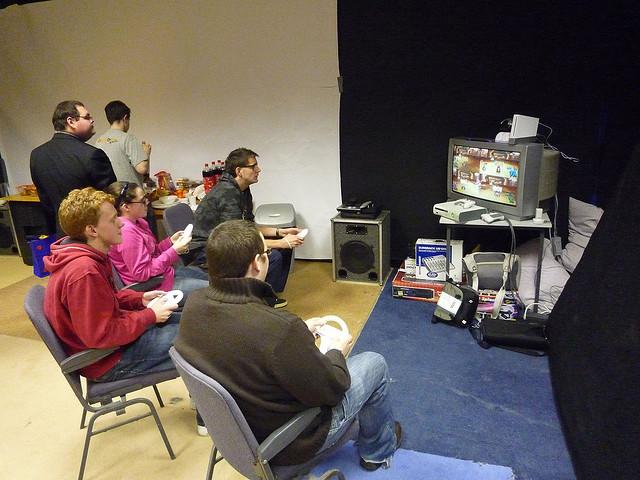How many people are sitting?
Write a very short answer. 4. What are the people staring at?
Concise answer only. Tv. What are the students sitting at?
Answer briefly. Tv. Does everyone have cups?
Quick response, please. No. What are the kids sitting in?
Quick response, please. Chairs. What color are the shoes?
Keep it brief. Brown. What are the kids doing?
Short answer required. Playing video games. What's on the man's lap?
Quick response, please. Controller. Is anyone wearing pink?
Answer briefly. Yes. How many people are wearing masks?
Be succinct. 0. Where is the laptop?
Short answer required. No laptop. What age group are most of these people in?
Be succinct. Teens. 